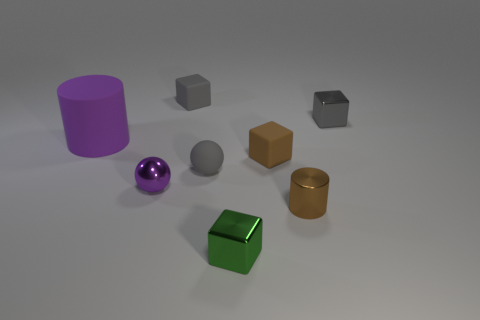What could be the function of the purple cylinder? Though it's hard to determine the function from the image alone, the purple cylinder could be a simple container, a decorative element, or perhaps a part of some larger apparatus, depending on its material and context. Based on its size, could it hold liquids like a cup? Given its size and open top, the purple cylinder could indeed function similarly to a cup, capable of holding liquids if required. 